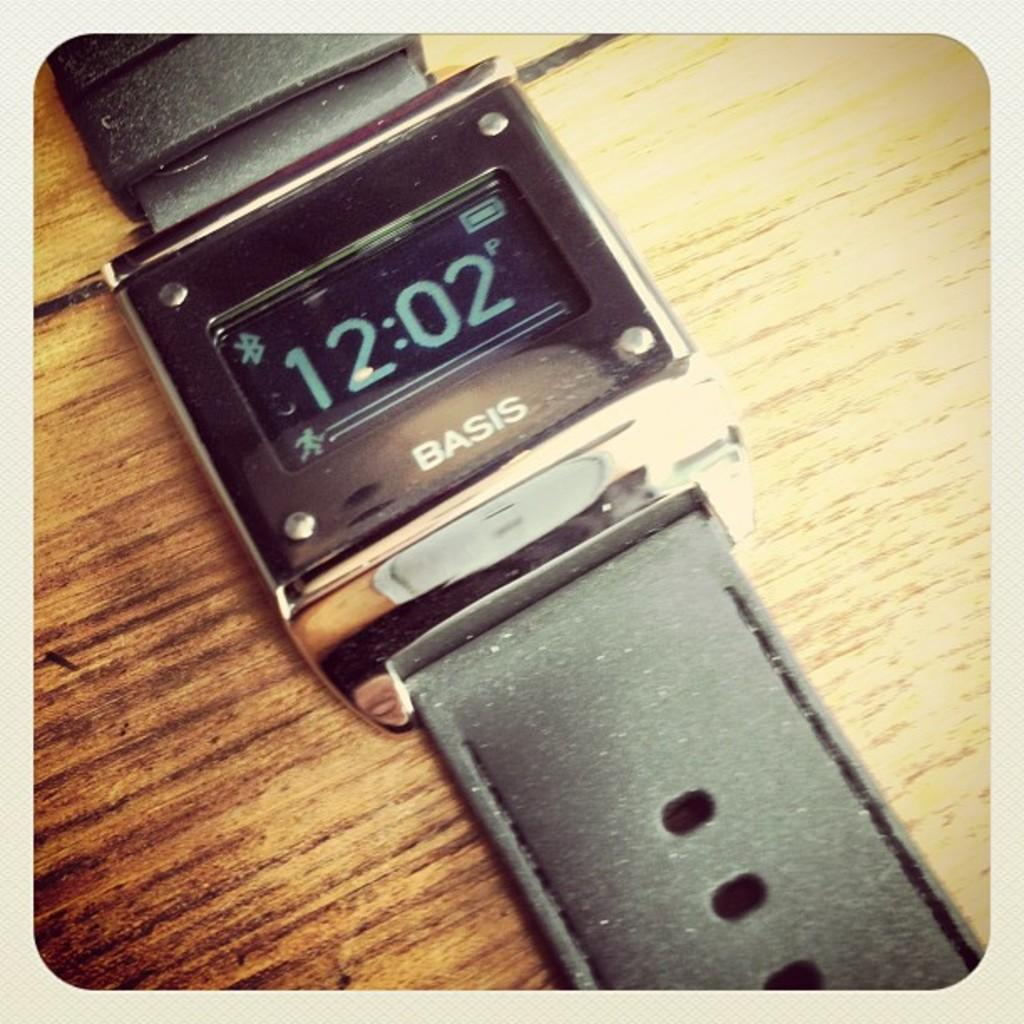Provide a one-sentence caption for the provided image. a Basis digital watch with a square face is laying on a wooden table. 